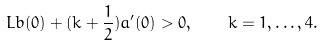Convert formula to latex. <formula><loc_0><loc_0><loc_500><loc_500>L b ( 0 ) + ( k + \frac { 1 } { 2 } ) a ^ { \prime } ( 0 ) > 0 , \quad k = 1 , \dots , 4 .</formula> 